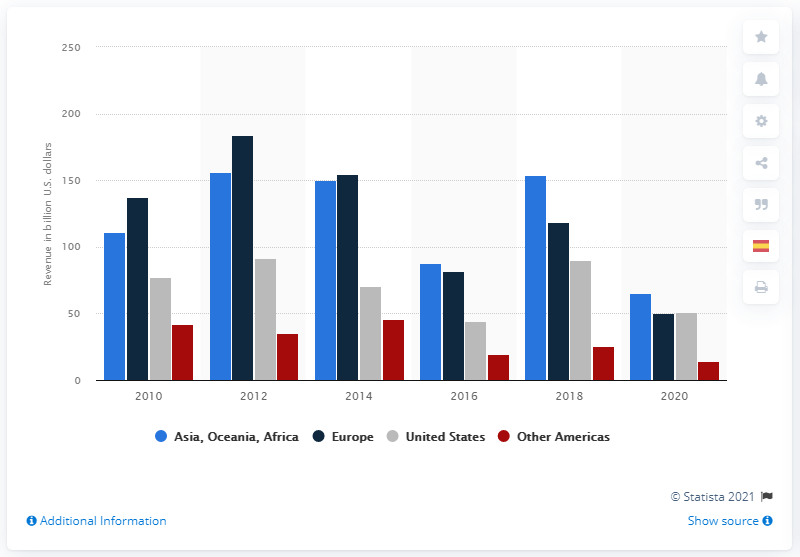Highlight a few significant elements in this photo. Royal Dutch Shell generated revenue of 65.14 billion in Asia, Oceania, and Africa in 2020. 